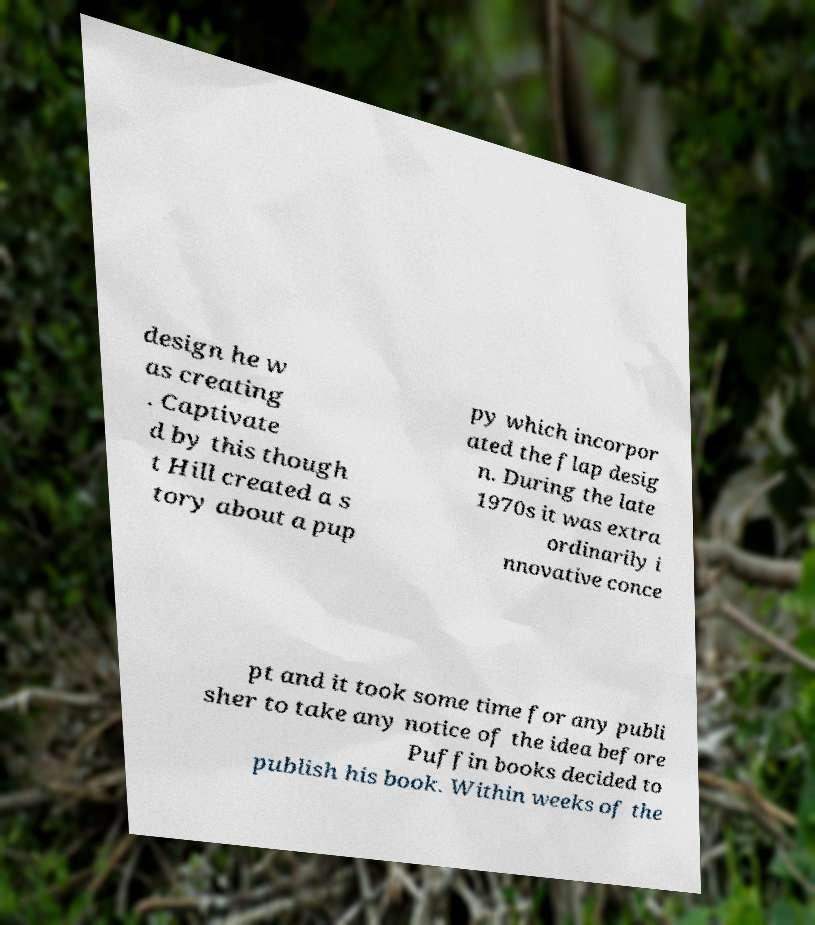Can you accurately transcribe the text from the provided image for me? design he w as creating . Captivate d by this though t Hill created a s tory about a pup py which incorpor ated the flap desig n. During the late 1970s it was extra ordinarily i nnovative conce pt and it took some time for any publi sher to take any notice of the idea before Puffin books decided to publish his book. Within weeks of the 